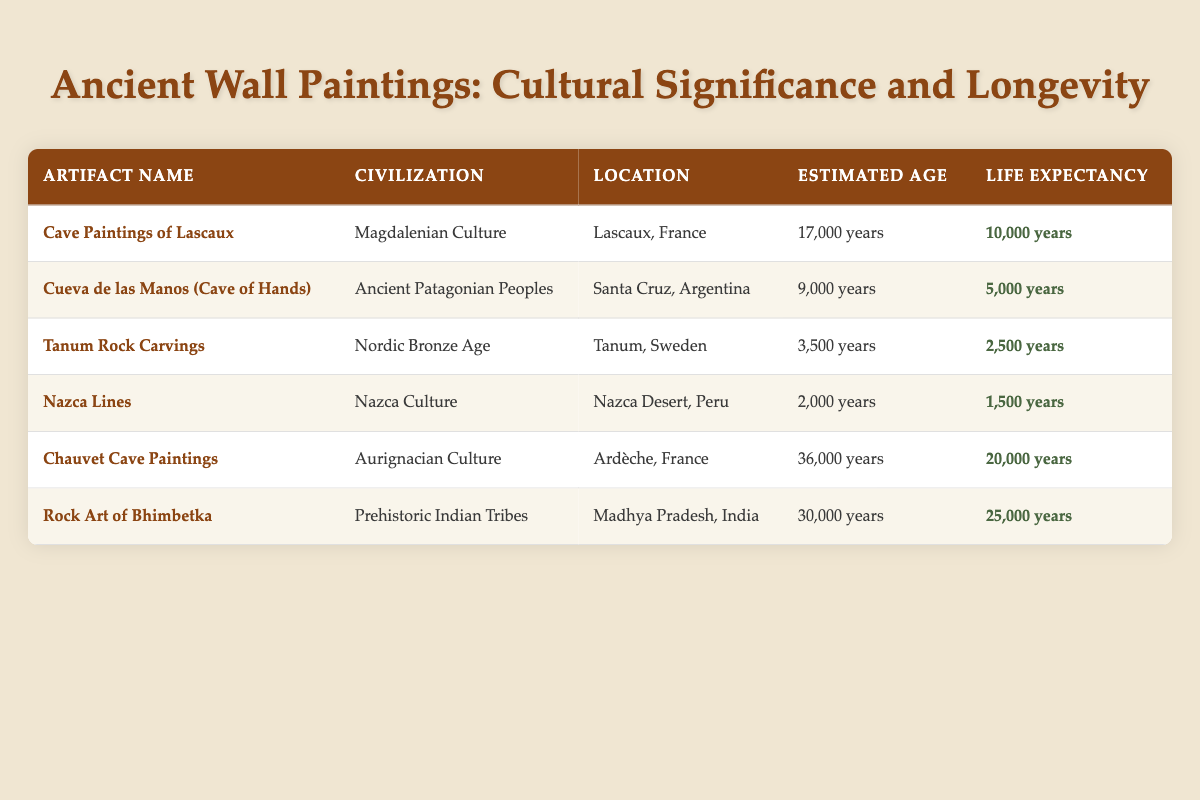What is the estimated age of the Cave Paintings of Lascaux? The estimated age is listed directly in the table under the "Estimated Age" column for the artifact "Cave Paintings of Lascaux." It shows "17,000 years."
Answer: 17,000 years Which artifact has the longest life expectancy? By inspecting the "Life Expectancy" column in the table, it can be seen that the "Rock Art of Bhimbetka" has the highest life expectancy at "25,000 years."
Answer: Rock Art of Bhimbetka Is the life expectancy of the Nazca Lines greater than that of the Cueva de las Manos? Comparing the life expectancy values in the table, the Nazca Lines have a life expectancy of "1,500 years" while the Cueva de las Manos has "5,000 years." Since 1,500 is less than 5,000, the statement is false.
Answer: No What is the average life expectancy of the artifacts from the Aurignacian Culture and the Magdalenian Culture? The life expectancies for the Aurignacian Culture (Chauvet Cave Paintings) and Magdalenian Culture (Cave Paintings of Lascaux) are "20,000 years" and "10,000 years," respectively. To find the average, we sum these two values: 20,000 + 10,000 = 30,000, and then divide by 2: 30,000 / 2 = 15,000.
Answer: 15,000 years Which civilization has artifacts that still exist beyond their estimated ages? By examining the "Estimated Age" and "Life Expectancy" columns, the results show that the Rock Art of Bhimbetka has an estimated age of "30,000 years" and a life expectancy of "25,000 years." This implies it has outlived its life expectancy. Other artifacts fall within their expected time frames.
Answer: Prehistoric Indian Tribes How many artifacts have a life expectancy greater than 10,000 years? The life expectancy values must be checked: the Cave Paintings of Lascaux (10,000 years, not greater), Chauvet Cave Paintings (20,000 years), and Rock Art of Bhimbetka (25,000 years). Thus, there are 2 artifacts with a life expectancy greater than 10,000 years.
Answer: 2 